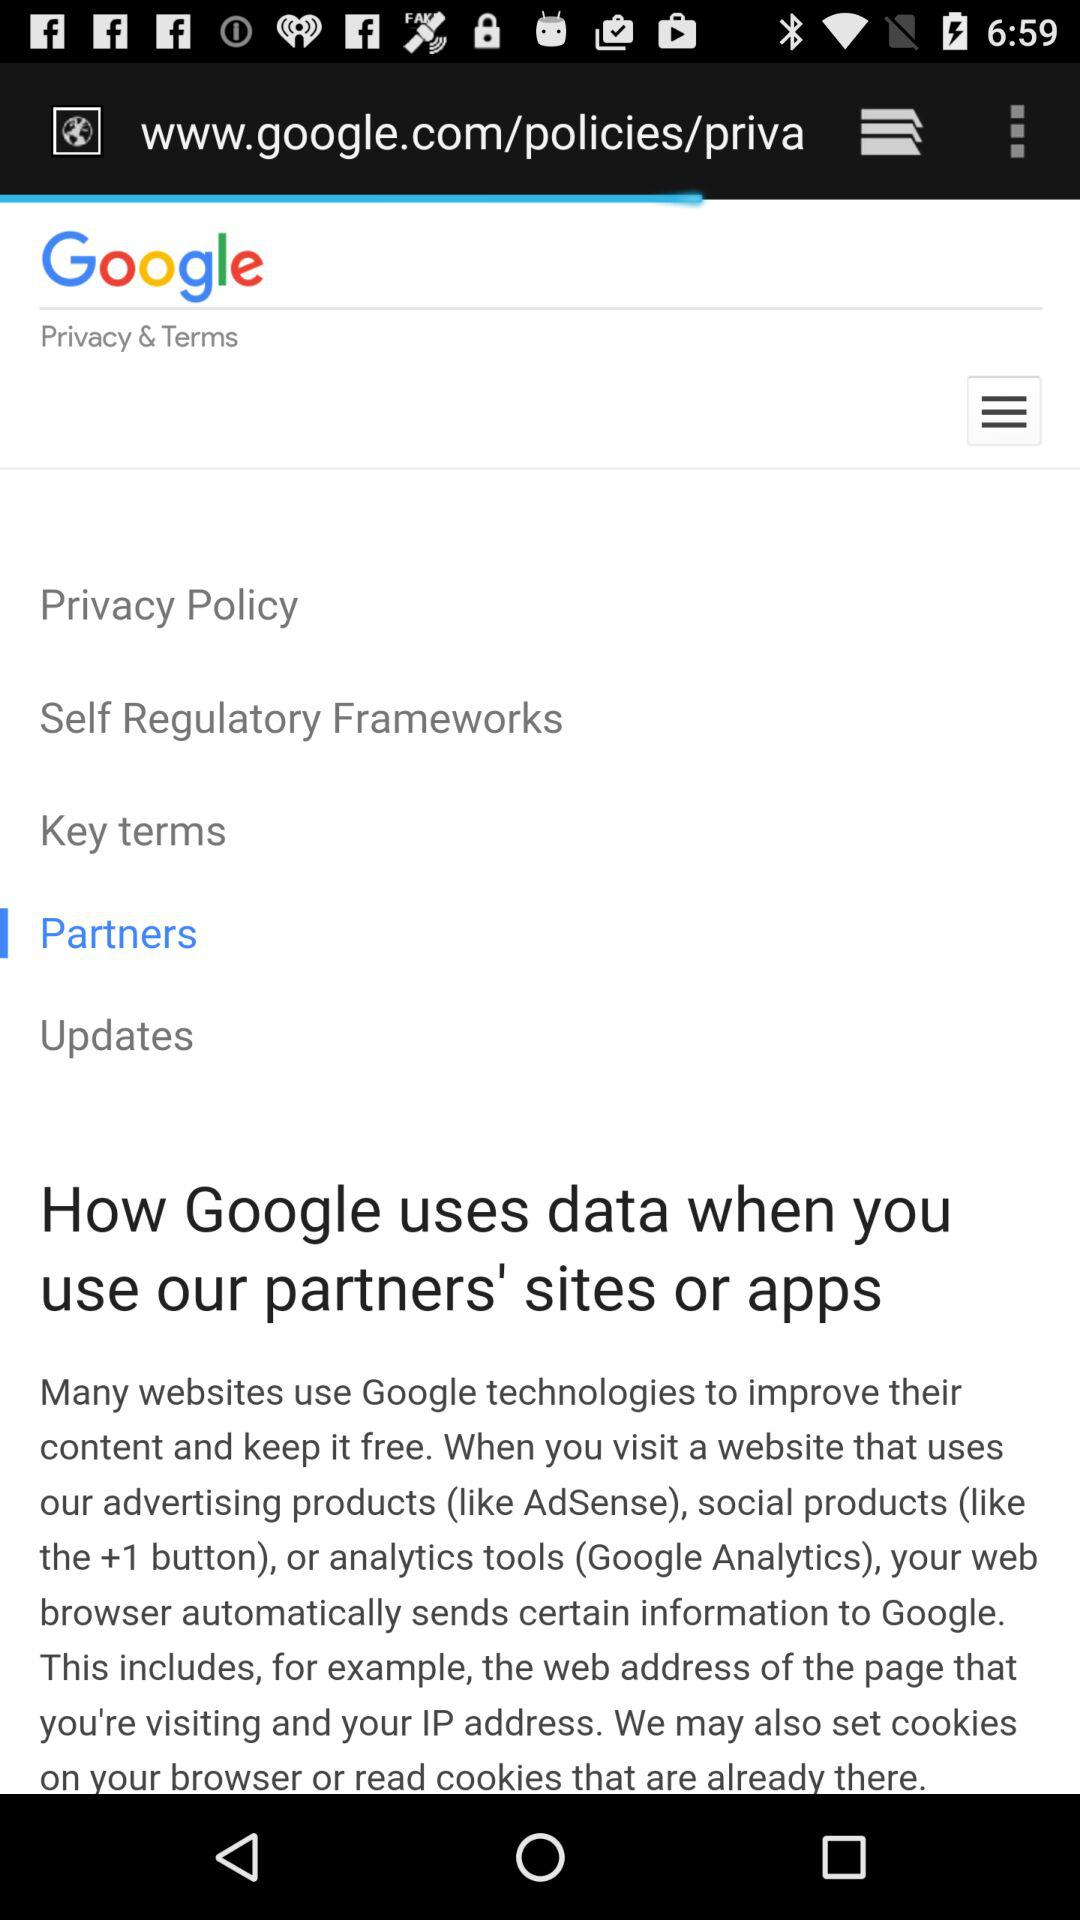When was the last update of the application made?
When the provided information is insufficient, respond with <no answer>. <no answer> 